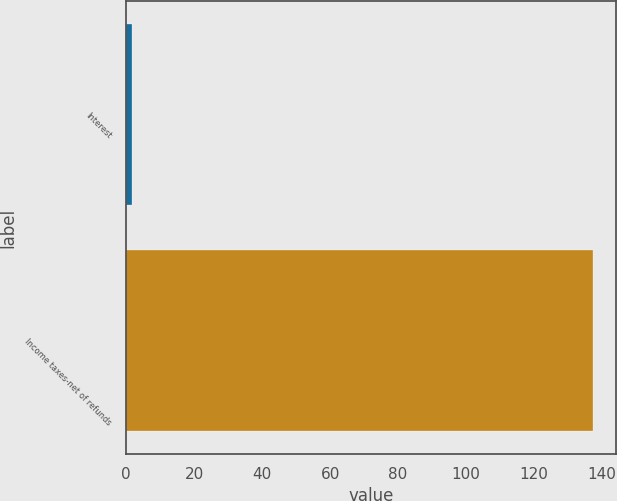Convert chart. <chart><loc_0><loc_0><loc_500><loc_500><bar_chart><fcel>Interest<fcel>Income taxes-net of refunds<nl><fcel>1.7<fcel>137.2<nl></chart> 